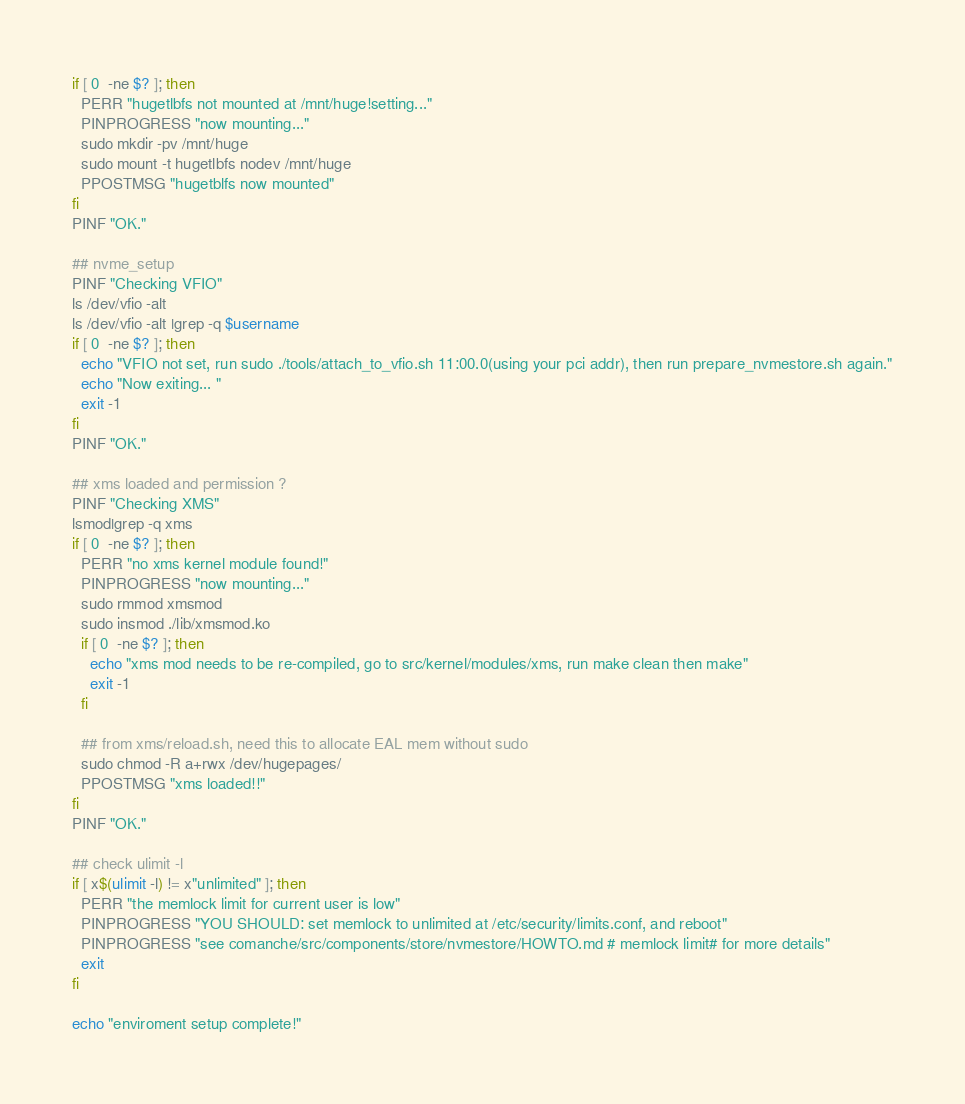Convert code to text. <code><loc_0><loc_0><loc_500><loc_500><_Bash_>if [ 0  -ne $? ]; then
  PERR "hugetlbfs not mounted at /mnt/huge!setting..."
  PINPROGRESS "now mounting..."
  sudo mkdir -pv /mnt/huge
  sudo mount -t hugetlbfs nodev /mnt/huge
  PPOSTMSG "hugetblfs now mounted"
fi
PINF "OK."

## nvme_setup
PINF "Checking VFIO"
ls /dev/vfio -alt
ls /dev/vfio -alt |grep -q $username
if [ 0  -ne $? ]; then
  echo "VFIO not set, run sudo ./tools/attach_to_vfio.sh 11:00.0(using your pci addr), then run prepare_nvmestore.sh again."
  echo "Now exiting... "
  exit -1
fi
PINF "OK."

## xms loaded and permission ?
PINF "Checking XMS"
lsmod|grep -q xms
if [ 0  -ne $? ]; then
  PERR "no xms kernel module found!"
  PINPROGRESS "now mounting..."
  sudo rmmod xmsmod
  sudo insmod ./lib/xmsmod.ko
  if [ 0  -ne $? ]; then
    echo "xms mod needs to be re-compiled, go to src/kernel/modules/xms, run make clean then make"
    exit -1
  fi

  ## from xms/reload.sh, need this to allocate EAL mem without sudo
  sudo chmod -R a+rwx /dev/hugepages/
  PPOSTMSG "xms loaded!!"
fi
PINF "OK."

## check ulimit -l
if [ x$(ulimit -l) != x"unlimited" ]; then
  PERR "the memlock limit for current user is low"
  PINPROGRESS "YOU SHOULD: set memlock to unlimited at /etc/security/limits.conf, and reboot"
  PINPROGRESS "see comanche/src/components/store/nvmestore/HOWTO.md # memlock limit# for more details"
  exit
fi

echo "enviroment setup complete!"
</code> 